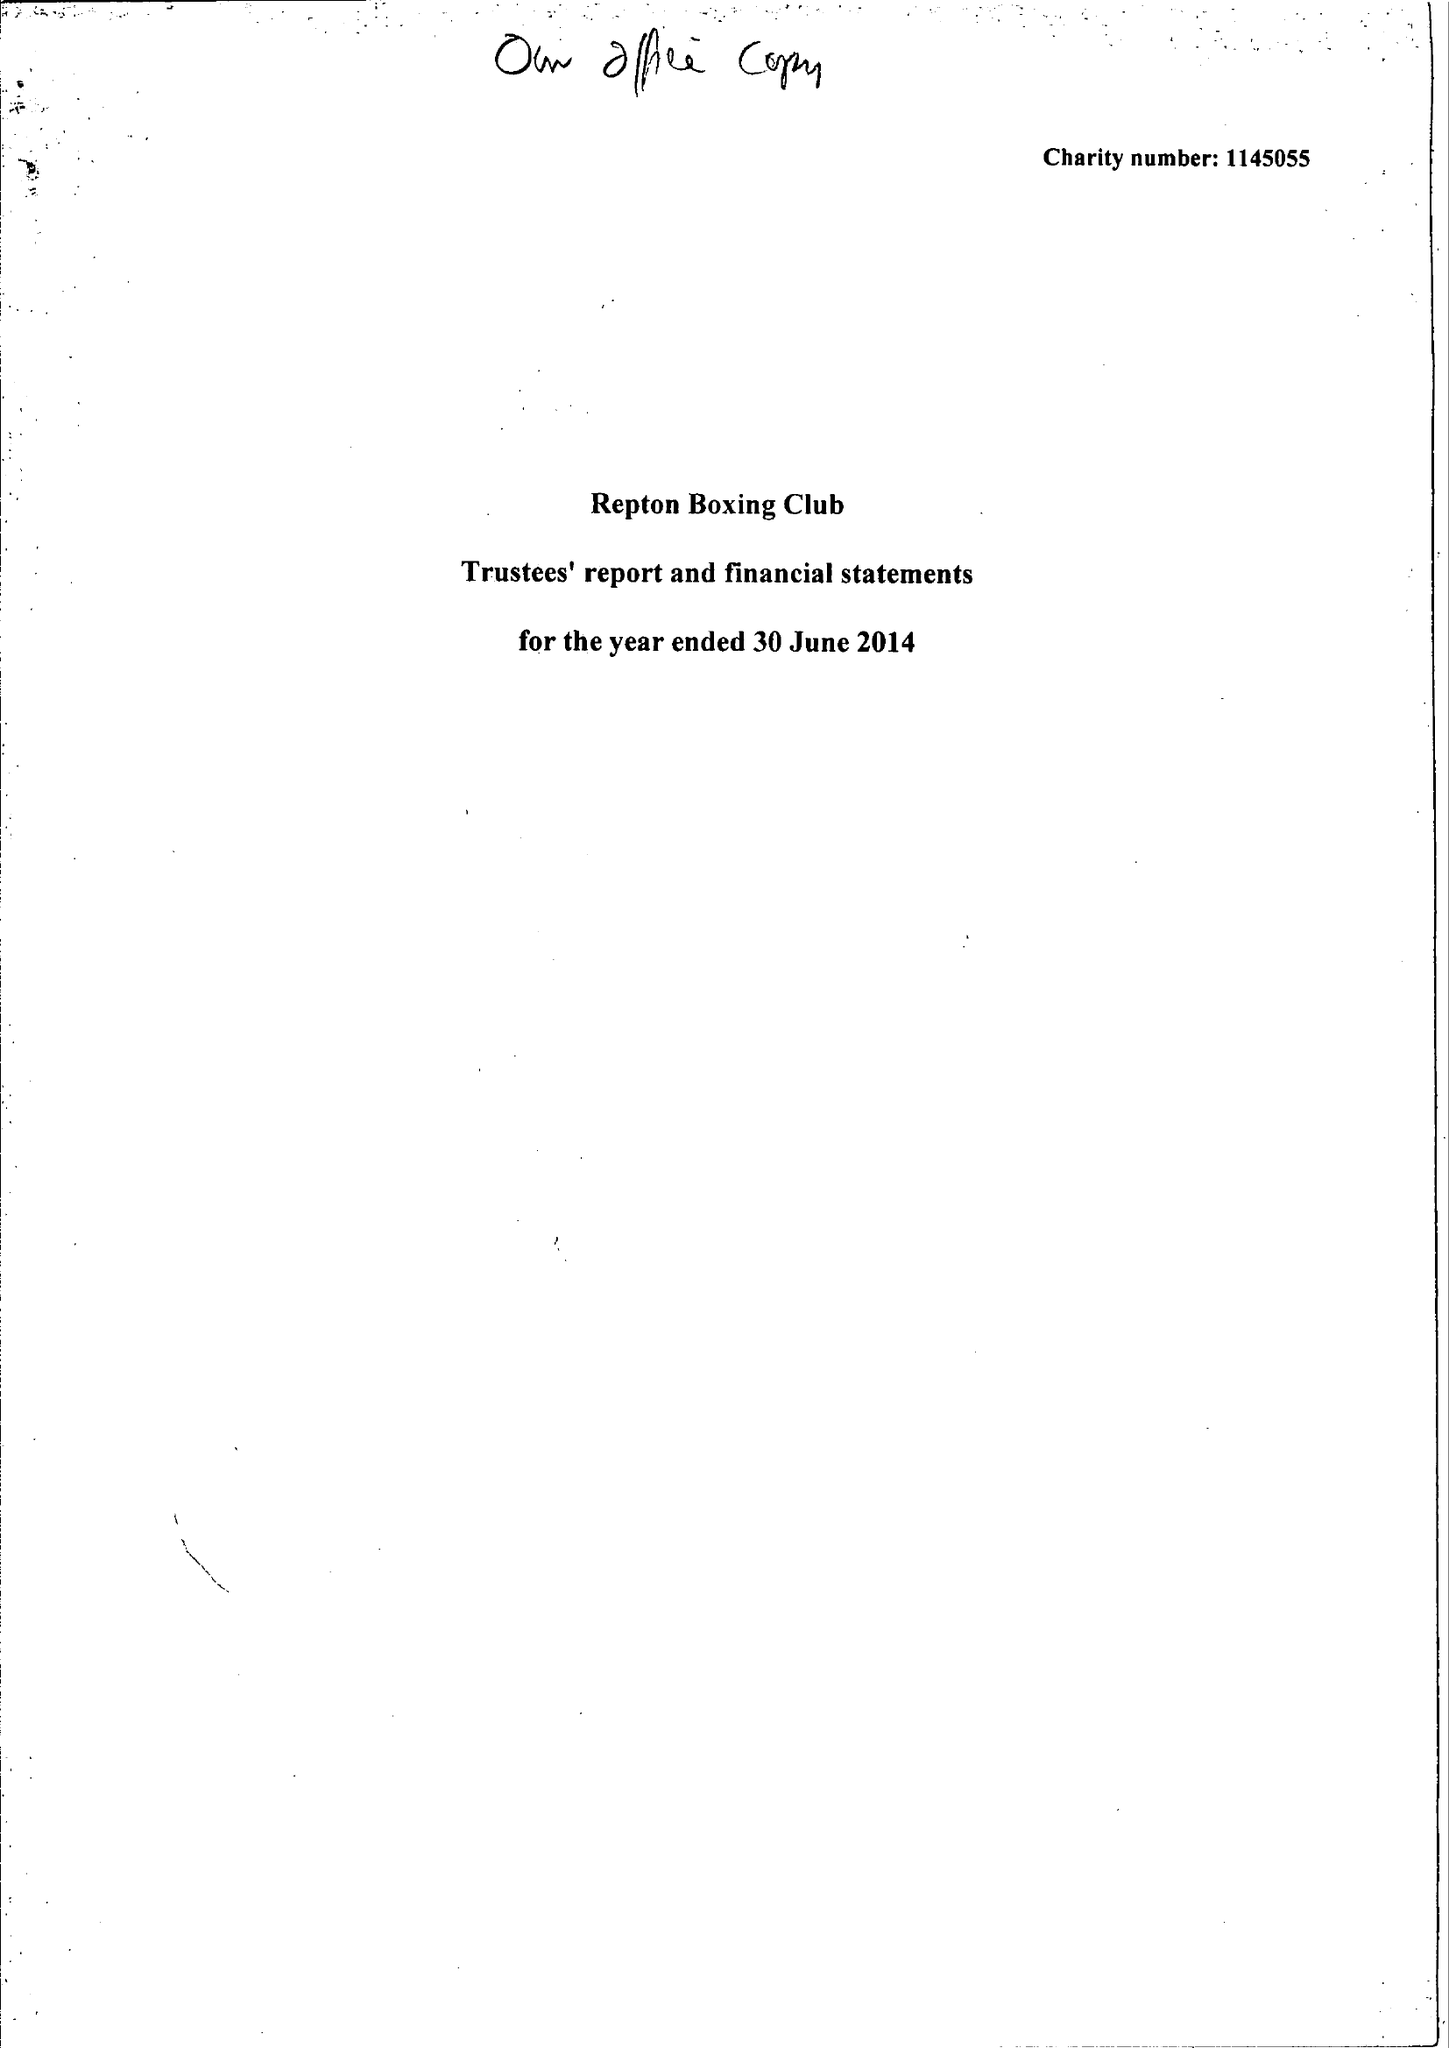What is the value for the address__postcode?
Answer the question using a single word or phrase. E2 7RH 